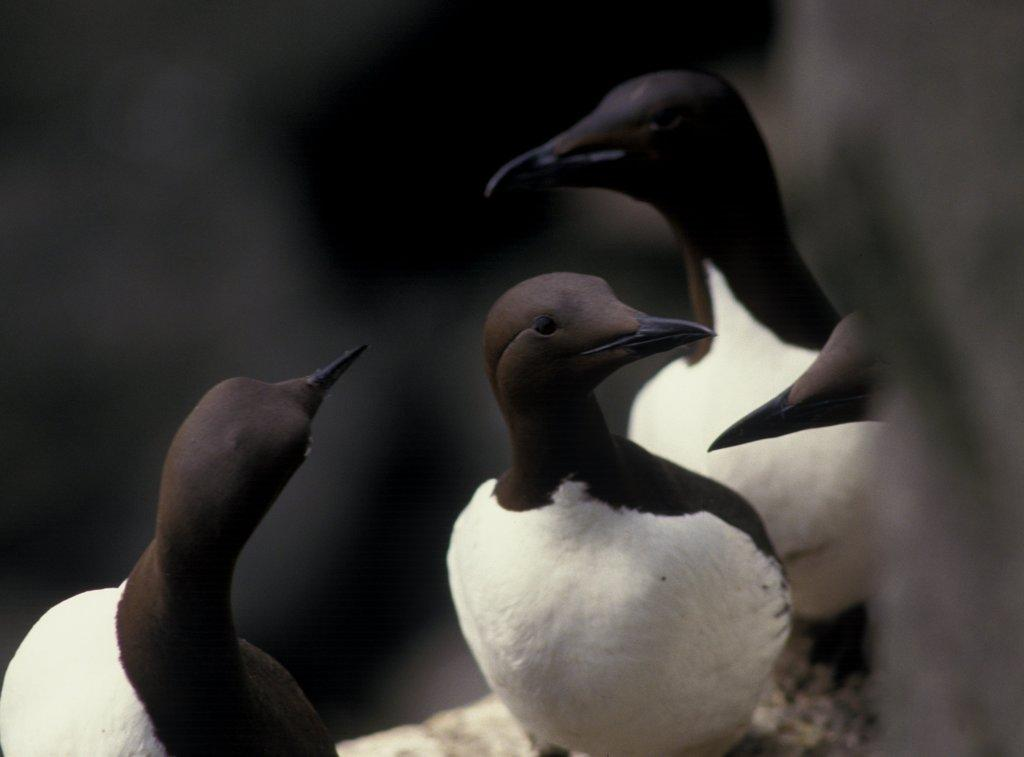What type of animals can be seen in the image? There are birds in the picture. What color are the birds in the image? The birds are in black and white color. Can you describe the background of the image? The background of the image is blurry. How many kittens are coughing in the image? There are no kittens or coughing sounds present in the image. 